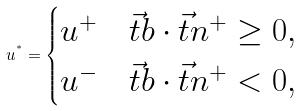<formula> <loc_0><loc_0><loc_500><loc_500>u ^ { ^ { * } } = \begin{cases} u ^ { + } & \vec { t } { b } \cdot \vec { t } { n ^ { + } } \geq 0 , \\ u ^ { - } & \vec { t } { b } \cdot \vec { t } { n ^ { + } } < 0 , \end{cases}</formula> 